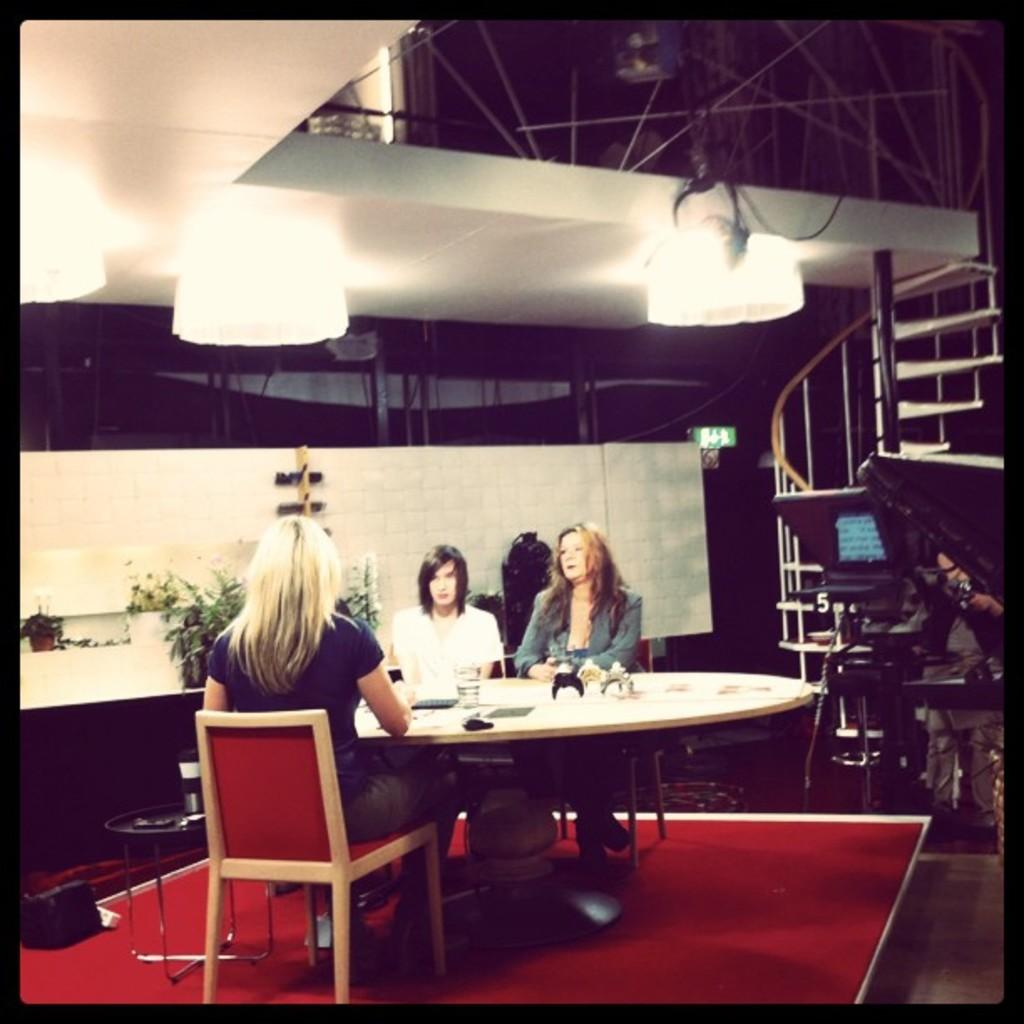How many people are sitting around the table in the image? There are three persons sitting on chairs around a table. What objects can be seen on the table? There is a glass, a book, and a toy on the table. What is visible in the background of the image? There is a wall, steps, and light in the background. What type of wristwatch is the person wearing in the image? There is no wristwatch visible on any of the persons in the image. What kind of harmony is being played by the ducks in the image? There are no ducks present in the image, and therefore no music or harmony can be heard. 